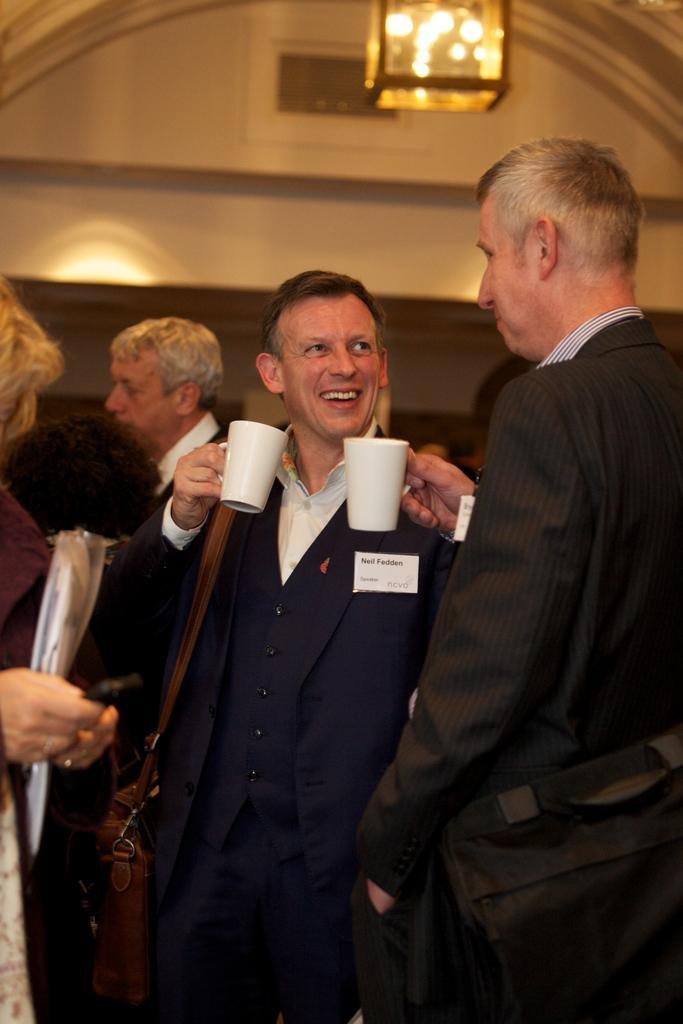How would you summarize this image in a sentence or two? There are some persons in the picture who are standing first two people are talking with each other by drinking a coffee in the background there is a light and a wall. 